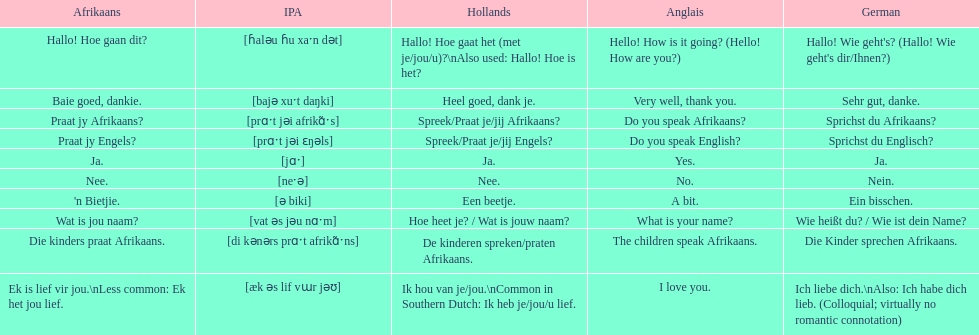Translate the following into english: 'n bietjie. A bit. 